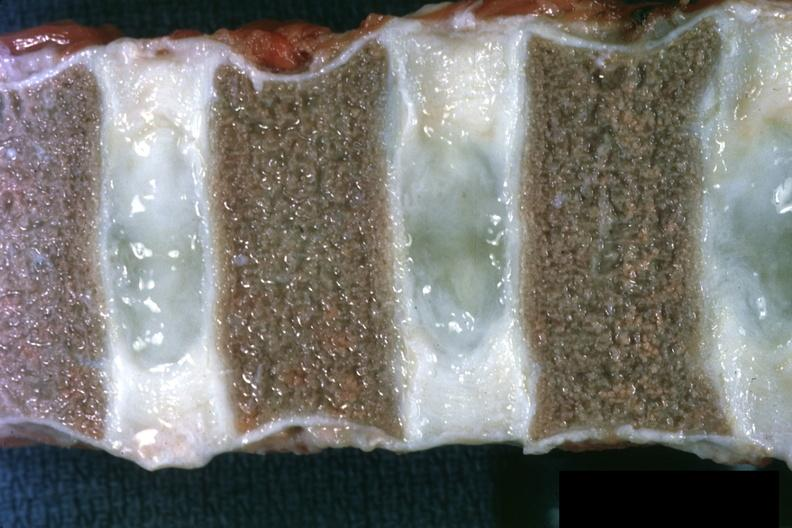s hematologic present?
Answer the question using a single word or phrase. Yes 